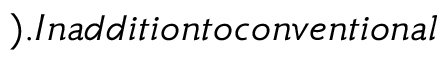Convert formula to latex. <formula><loc_0><loc_0><loc_500><loc_500>) . I n a d d i t i o n t o c o n v e n t i o n a l</formula> 